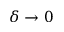Convert formula to latex. <formula><loc_0><loc_0><loc_500><loc_500>\delta \to 0</formula> 